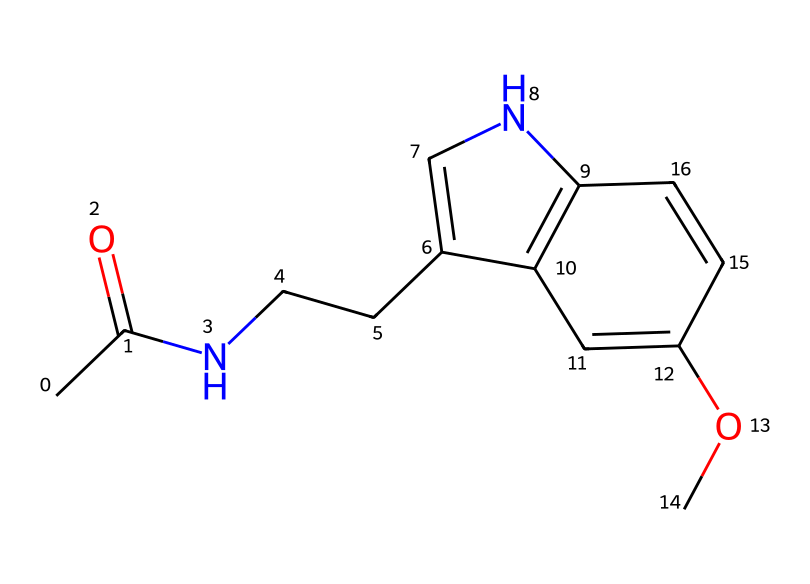What is the molecular formula of this compound? To determine the molecular formula, we can count the number of each type of atom in the SMILES representation. The carbon (C) is counted as 13, hydrogen (H) as 16, nitrogen (N) as 2, and oxygen (O) as 1. Thus, the molecular formula becomes C13H16N2O.
Answer: C13H16N2O How many rings are present in the structure? Observing the SMILES representation, we note the presence of a cyclic structure indicated by "1" in the notation. There is one cyclic structure in the compound.
Answer: 1 Does this compound contain nitrogen? By examining the SMILES structure, we see that there is a nitrogen atom (N) present in the compound.
Answer: Yes What type of compound is this based on its biological function? This compound is known for its role in regulating sleep and is classified as a hormone.
Answer: Hormone How many double bonds are there in the molecule? In the chemical structure, we identify the presence of double bonds through the "=" symbol in the SMILES. In this structure, there are two double bonds detected.
Answer: 2 What functional groups are present in the molecule? Looking closely at the structure, we recognize the presence of an acetyl group (indicated by CC(=O)) and an ether group (denoted by the -OC). Both functional groups contribute to the overall properties of the compound.
Answer: Acetyl and ether What role does the indole structure play in this compound? The indole structure, characterized by a fused benzene and pyrrole ring, is crucial for the biological activity of this hormone as it contributes to its interaction with specific receptors in the body.
Answer: Biological activity 